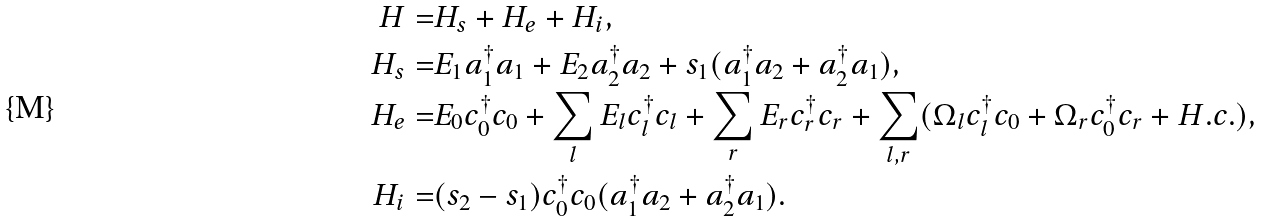Convert formula to latex. <formula><loc_0><loc_0><loc_500><loc_500>H = & H _ { s } + H _ { e } + H _ { i } , \\ H _ { s } = & E _ { 1 } a _ { 1 } ^ { \dagger } a _ { 1 } + E _ { 2 } a _ { 2 } ^ { \dagger } a _ { 2 } + s _ { 1 } ( a _ { 1 } ^ { \dagger } a _ { 2 } + a _ { 2 } ^ { \dagger } a _ { 1 } ) , \\ H _ { e } = & E _ { 0 } c _ { 0 } ^ { \dagger } c _ { 0 } + \sum _ { l } E _ { l } c _ { l } ^ { \dagger } c _ { l } + \sum _ { r } E _ { r } c _ { r } ^ { \dagger } c _ { r } + \sum _ { l , r } ( \Omega _ { l } c _ { l } ^ { \dagger } c _ { 0 } + \Omega _ { r } c _ { 0 } ^ { \dagger } c _ { r } + H . c . ) , \\ H _ { i } = & ( s _ { 2 } - s _ { 1 } ) c _ { 0 } ^ { \dagger } c _ { 0 } ( a _ { 1 } ^ { \dagger } a _ { 2 } + a _ { 2 } ^ { \dagger } a _ { 1 } ) .</formula> 